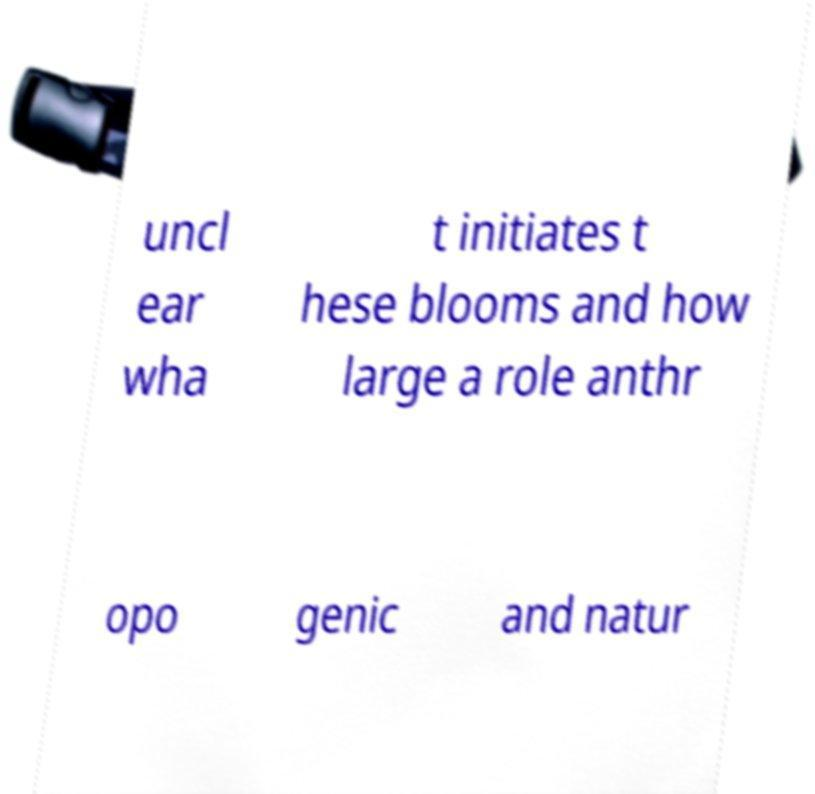Please identify and transcribe the text found in this image. uncl ear wha t initiates t hese blooms and how large a role anthr opo genic and natur 